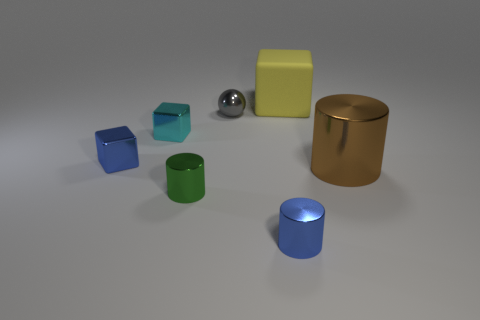Subtract 1 cylinders. How many cylinders are left? 2 Add 1 tiny cyan cubes. How many objects exist? 8 Subtract all spheres. How many objects are left? 6 Subtract all green shiny cylinders. Subtract all green cylinders. How many objects are left? 5 Add 1 metal spheres. How many metal spheres are left? 2 Add 3 gray matte cubes. How many gray matte cubes exist? 3 Subtract 1 gray spheres. How many objects are left? 6 